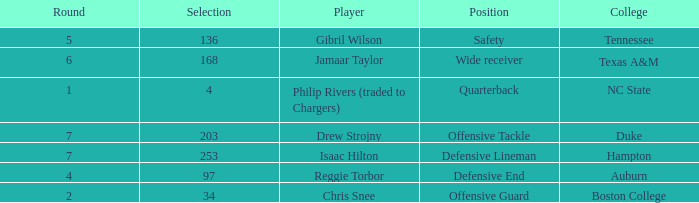Would you be able to parse every entry in this table? {'header': ['Round', 'Selection', 'Player', 'Position', 'College'], 'rows': [['5', '136', 'Gibril Wilson', 'Safety', 'Tennessee'], ['6', '168', 'Jamaar Taylor', 'Wide receiver', 'Texas A&M'], ['1', '4', 'Philip Rivers (traded to Chargers)', 'Quarterback', 'NC State'], ['7', '203', 'Drew Strojny', 'Offensive Tackle', 'Duke'], ['7', '253', 'Isaac Hilton', 'Defensive Lineman', 'Hampton'], ['4', '97', 'Reggie Torbor', 'Defensive End', 'Auburn'], ['2', '34', 'Chris Snee', 'Offensive Guard', 'Boston College']]} Which Position has a Player of gibril wilson? Safety. 